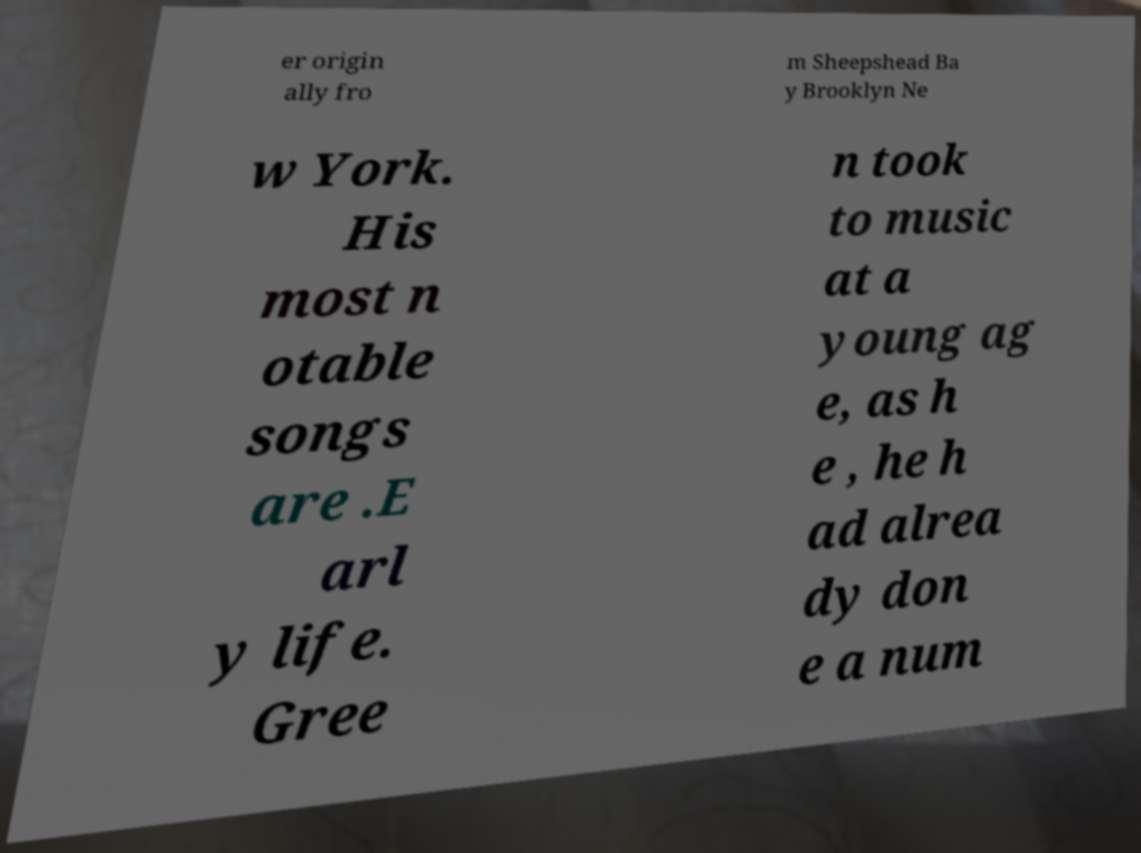Please read and relay the text visible in this image. What does it say? er origin ally fro m Sheepshead Ba y Brooklyn Ne w York. His most n otable songs are .E arl y life. Gree n took to music at a young ag e, as h e , he h ad alrea dy don e a num 